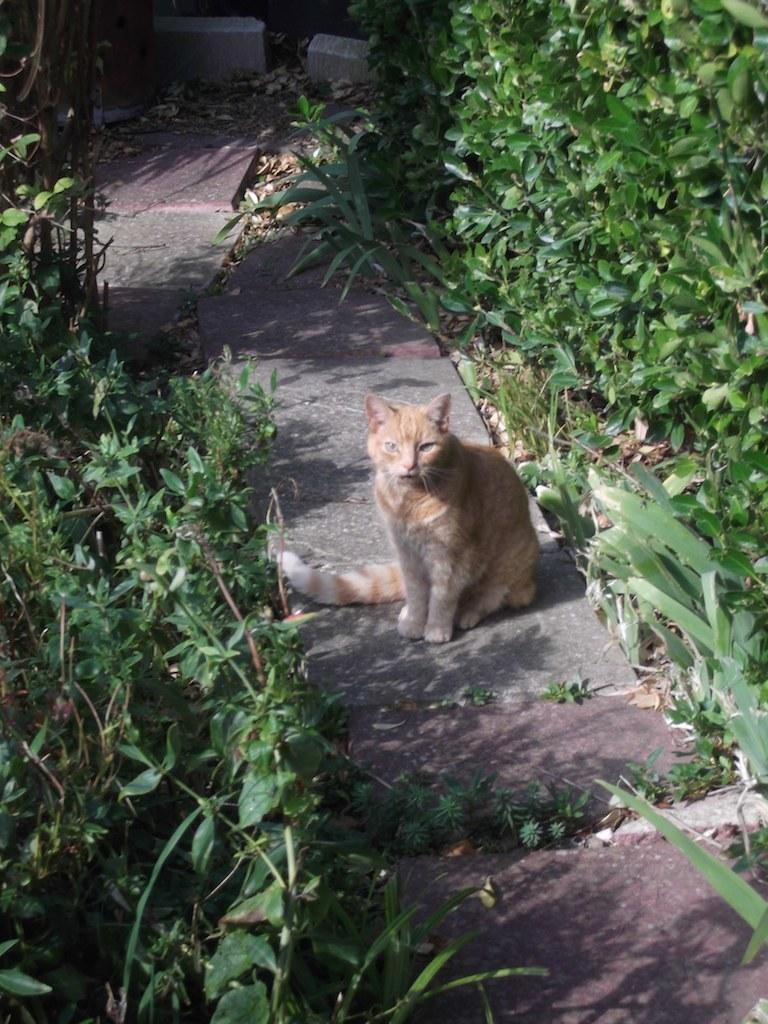What is the main subject in the center of the image? There is a cat in the center of the image. What is located at the bottom of the image? There are laystones at the bottom of the image. What type of vegetation can be seen in the background of the image? There are bushes and plants in the background of the image. What is the size of the twig that the cat is holding in the image? There is no twig present in the image, and therefore no such activity can be observed. 